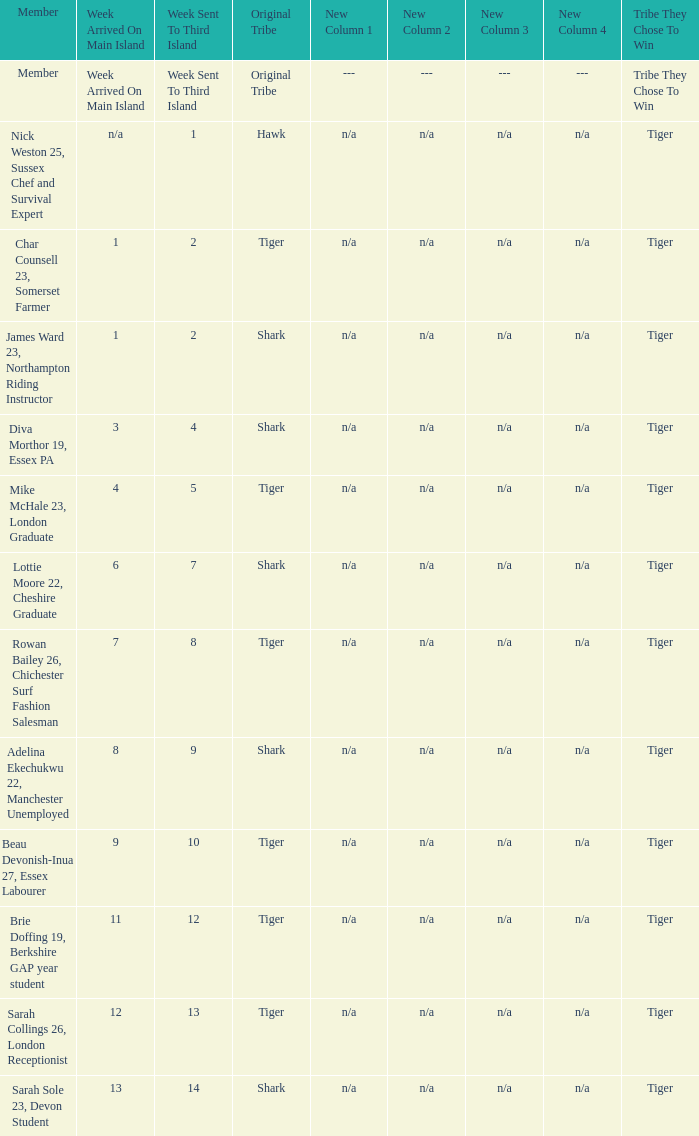What week was the member who arrived on the main island in week 6 sent to the third island? 7.0. 